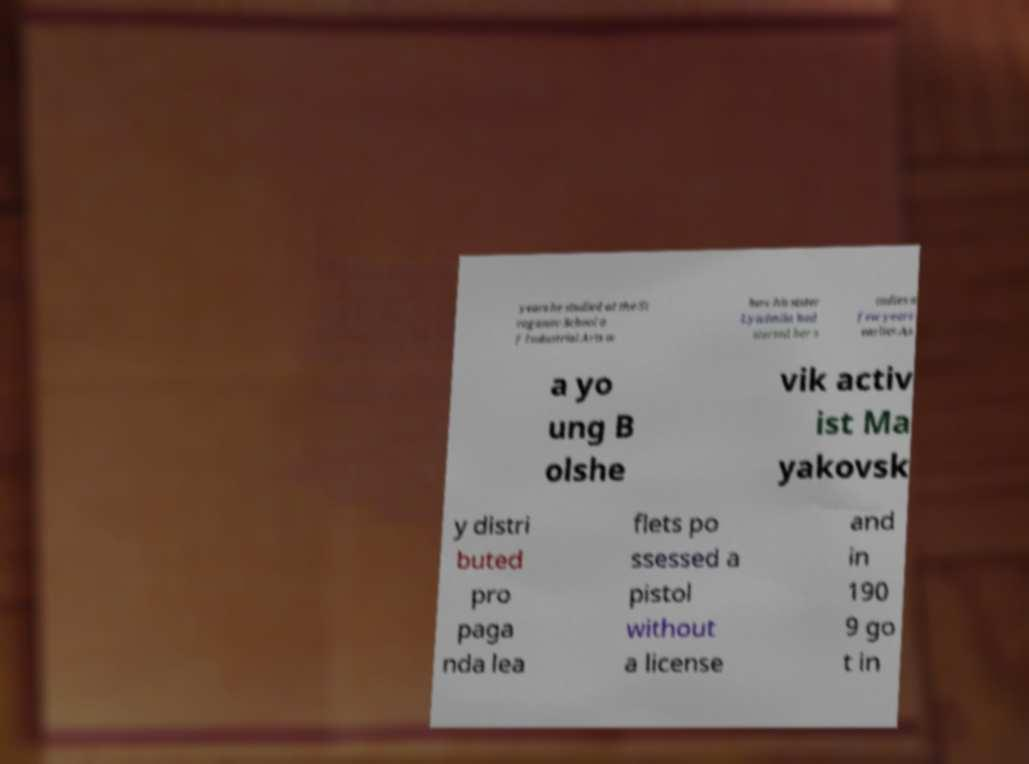I need the written content from this picture converted into text. Can you do that? years he studied at the St roganov School o f Industrial Arts w here his sister Lyudmila had started her s tudies a few years earlier.As a yo ung B olshe vik activ ist Ma yakovsk y distri buted pro paga nda lea flets po ssessed a pistol without a license and in 190 9 go t in 